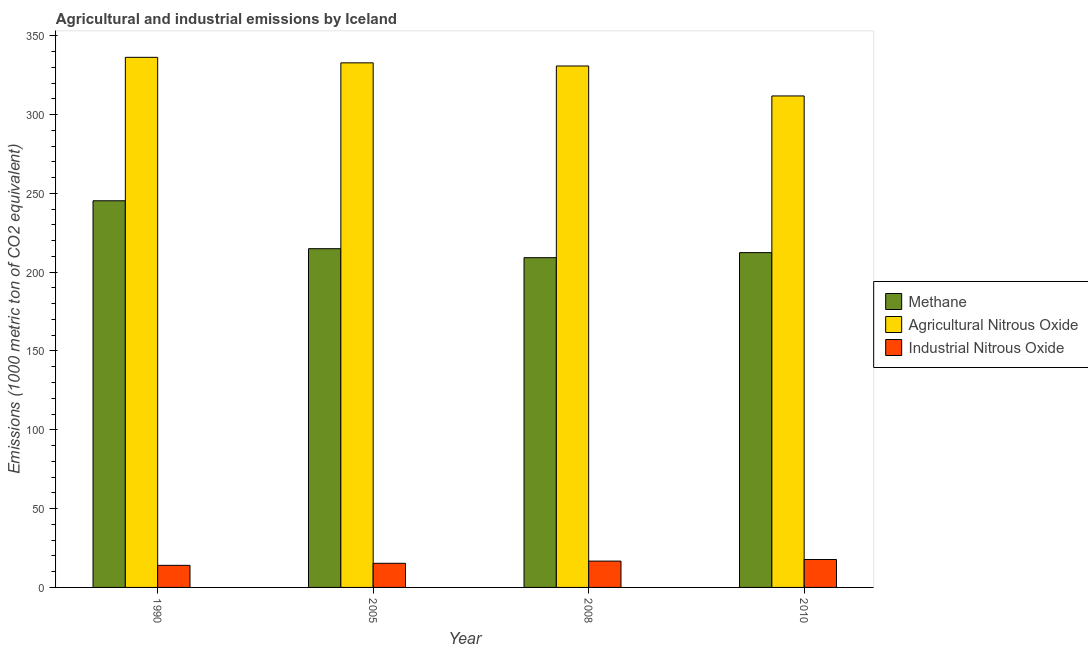Are the number of bars per tick equal to the number of legend labels?
Your response must be concise. Yes. Are the number of bars on each tick of the X-axis equal?
Make the answer very short. Yes. In how many cases, is the number of bars for a given year not equal to the number of legend labels?
Provide a short and direct response. 0. What is the amount of industrial nitrous oxide emissions in 2010?
Your response must be concise. 17.7. Across all years, what is the maximum amount of methane emissions?
Make the answer very short. 245.3. Across all years, what is the minimum amount of methane emissions?
Ensure brevity in your answer.  209.2. What is the total amount of agricultural nitrous oxide emissions in the graph?
Make the answer very short. 1311.7. What is the difference between the amount of industrial nitrous oxide emissions in 2005 and that in 2008?
Make the answer very short. -1.4. What is the difference between the amount of methane emissions in 2010 and the amount of industrial nitrous oxide emissions in 1990?
Keep it short and to the point. -32.9. What is the average amount of industrial nitrous oxide emissions per year?
Make the answer very short. 15.93. What is the ratio of the amount of industrial nitrous oxide emissions in 1990 to that in 2005?
Your answer should be compact. 0.92. Is the amount of methane emissions in 2005 less than that in 2010?
Give a very brief answer. No. What is the difference between the highest and the second highest amount of methane emissions?
Ensure brevity in your answer.  30.4. What is the difference between the highest and the lowest amount of methane emissions?
Give a very brief answer. 36.1. What does the 2nd bar from the left in 2005 represents?
Your response must be concise. Agricultural Nitrous Oxide. What does the 2nd bar from the right in 2005 represents?
Give a very brief answer. Agricultural Nitrous Oxide. Is it the case that in every year, the sum of the amount of methane emissions and amount of agricultural nitrous oxide emissions is greater than the amount of industrial nitrous oxide emissions?
Your response must be concise. Yes. Are all the bars in the graph horizontal?
Provide a succinct answer. No. How many years are there in the graph?
Provide a succinct answer. 4. What is the difference between two consecutive major ticks on the Y-axis?
Your response must be concise. 50. Are the values on the major ticks of Y-axis written in scientific E-notation?
Provide a short and direct response. No. Does the graph contain any zero values?
Make the answer very short. No. How many legend labels are there?
Keep it short and to the point. 3. What is the title of the graph?
Offer a terse response. Agricultural and industrial emissions by Iceland. What is the label or title of the Y-axis?
Provide a succinct answer. Emissions (1000 metric ton of CO2 equivalent). What is the Emissions (1000 metric ton of CO2 equivalent) in Methane in 1990?
Offer a terse response. 245.3. What is the Emissions (1000 metric ton of CO2 equivalent) of Agricultural Nitrous Oxide in 1990?
Provide a succinct answer. 336.3. What is the Emissions (1000 metric ton of CO2 equivalent) in Industrial Nitrous Oxide in 1990?
Provide a succinct answer. 14. What is the Emissions (1000 metric ton of CO2 equivalent) of Methane in 2005?
Provide a succinct answer. 214.9. What is the Emissions (1000 metric ton of CO2 equivalent) of Agricultural Nitrous Oxide in 2005?
Your answer should be very brief. 332.8. What is the Emissions (1000 metric ton of CO2 equivalent) in Industrial Nitrous Oxide in 2005?
Keep it short and to the point. 15.3. What is the Emissions (1000 metric ton of CO2 equivalent) in Methane in 2008?
Offer a very short reply. 209.2. What is the Emissions (1000 metric ton of CO2 equivalent) of Agricultural Nitrous Oxide in 2008?
Make the answer very short. 330.8. What is the Emissions (1000 metric ton of CO2 equivalent) of Industrial Nitrous Oxide in 2008?
Offer a very short reply. 16.7. What is the Emissions (1000 metric ton of CO2 equivalent) of Methane in 2010?
Ensure brevity in your answer.  212.4. What is the Emissions (1000 metric ton of CO2 equivalent) of Agricultural Nitrous Oxide in 2010?
Provide a succinct answer. 311.8. What is the Emissions (1000 metric ton of CO2 equivalent) in Industrial Nitrous Oxide in 2010?
Ensure brevity in your answer.  17.7. Across all years, what is the maximum Emissions (1000 metric ton of CO2 equivalent) of Methane?
Your response must be concise. 245.3. Across all years, what is the maximum Emissions (1000 metric ton of CO2 equivalent) in Agricultural Nitrous Oxide?
Make the answer very short. 336.3. Across all years, what is the minimum Emissions (1000 metric ton of CO2 equivalent) of Methane?
Offer a terse response. 209.2. Across all years, what is the minimum Emissions (1000 metric ton of CO2 equivalent) in Agricultural Nitrous Oxide?
Ensure brevity in your answer.  311.8. Across all years, what is the minimum Emissions (1000 metric ton of CO2 equivalent) of Industrial Nitrous Oxide?
Provide a short and direct response. 14. What is the total Emissions (1000 metric ton of CO2 equivalent) of Methane in the graph?
Provide a succinct answer. 881.8. What is the total Emissions (1000 metric ton of CO2 equivalent) in Agricultural Nitrous Oxide in the graph?
Your response must be concise. 1311.7. What is the total Emissions (1000 metric ton of CO2 equivalent) in Industrial Nitrous Oxide in the graph?
Your answer should be compact. 63.7. What is the difference between the Emissions (1000 metric ton of CO2 equivalent) of Methane in 1990 and that in 2005?
Your response must be concise. 30.4. What is the difference between the Emissions (1000 metric ton of CO2 equivalent) of Industrial Nitrous Oxide in 1990 and that in 2005?
Give a very brief answer. -1.3. What is the difference between the Emissions (1000 metric ton of CO2 equivalent) in Methane in 1990 and that in 2008?
Offer a very short reply. 36.1. What is the difference between the Emissions (1000 metric ton of CO2 equivalent) of Agricultural Nitrous Oxide in 1990 and that in 2008?
Offer a terse response. 5.5. What is the difference between the Emissions (1000 metric ton of CO2 equivalent) in Industrial Nitrous Oxide in 1990 and that in 2008?
Keep it short and to the point. -2.7. What is the difference between the Emissions (1000 metric ton of CO2 equivalent) in Methane in 1990 and that in 2010?
Ensure brevity in your answer.  32.9. What is the difference between the Emissions (1000 metric ton of CO2 equivalent) of Industrial Nitrous Oxide in 1990 and that in 2010?
Give a very brief answer. -3.7. What is the difference between the Emissions (1000 metric ton of CO2 equivalent) of Methane in 2005 and that in 2008?
Your response must be concise. 5.7. What is the difference between the Emissions (1000 metric ton of CO2 equivalent) in Methane in 2005 and that in 2010?
Provide a short and direct response. 2.5. What is the difference between the Emissions (1000 metric ton of CO2 equivalent) of Methane in 2008 and that in 2010?
Your response must be concise. -3.2. What is the difference between the Emissions (1000 metric ton of CO2 equivalent) of Agricultural Nitrous Oxide in 2008 and that in 2010?
Offer a very short reply. 19. What is the difference between the Emissions (1000 metric ton of CO2 equivalent) in Industrial Nitrous Oxide in 2008 and that in 2010?
Offer a very short reply. -1. What is the difference between the Emissions (1000 metric ton of CO2 equivalent) in Methane in 1990 and the Emissions (1000 metric ton of CO2 equivalent) in Agricultural Nitrous Oxide in 2005?
Make the answer very short. -87.5. What is the difference between the Emissions (1000 metric ton of CO2 equivalent) in Methane in 1990 and the Emissions (1000 metric ton of CO2 equivalent) in Industrial Nitrous Oxide in 2005?
Provide a short and direct response. 230. What is the difference between the Emissions (1000 metric ton of CO2 equivalent) in Agricultural Nitrous Oxide in 1990 and the Emissions (1000 metric ton of CO2 equivalent) in Industrial Nitrous Oxide in 2005?
Your answer should be very brief. 321. What is the difference between the Emissions (1000 metric ton of CO2 equivalent) of Methane in 1990 and the Emissions (1000 metric ton of CO2 equivalent) of Agricultural Nitrous Oxide in 2008?
Ensure brevity in your answer.  -85.5. What is the difference between the Emissions (1000 metric ton of CO2 equivalent) of Methane in 1990 and the Emissions (1000 metric ton of CO2 equivalent) of Industrial Nitrous Oxide in 2008?
Provide a succinct answer. 228.6. What is the difference between the Emissions (1000 metric ton of CO2 equivalent) in Agricultural Nitrous Oxide in 1990 and the Emissions (1000 metric ton of CO2 equivalent) in Industrial Nitrous Oxide in 2008?
Offer a terse response. 319.6. What is the difference between the Emissions (1000 metric ton of CO2 equivalent) of Methane in 1990 and the Emissions (1000 metric ton of CO2 equivalent) of Agricultural Nitrous Oxide in 2010?
Your answer should be compact. -66.5. What is the difference between the Emissions (1000 metric ton of CO2 equivalent) in Methane in 1990 and the Emissions (1000 metric ton of CO2 equivalent) in Industrial Nitrous Oxide in 2010?
Ensure brevity in your answer.  227.6. What is the difference between the Emissions (1000 metric ton of CO2 equivalent) in Agricultural Nitrous Oxide in 1990 and the Emissions (1000 metric ton of CO2 equivalent) in Industrial Nitrous Oxide in 2010?
Give a very brief answer. 318.6. What is the difference between the Emissions (1000 metric ton of CO2 equivalent) in Methane in 2005 and the Emissions (1000 metric ton of CO2 equivalent) in Agricultural Nitrous Oxide in 2008?
Make the answer very short. -115.9. What is the difference between the Emissions (1000 metric ton of CO2 equivalent) in Methane in 2005 and the Emissions (1000 metric ton of CO2 equivalent) in Industrial Nitrous Oxide in 2008?
Make the answer very short. 198.2. What is the difference between the Emissions (1000 metric ton of CO2 equivalent) in Agricultural Nitrous Oxide in 2005 and the Emissions (1000 metric ton of CO2 equivalent) in Industrial Nitrous Oxide in 2008?
Your answer should be compact. 316.1. What is the difference between the Emissions (1000 metric ton of CO2 equivalent) in Methane in 2005 and the Emissions (1000 metric ton of CO2 equivalent) in Agricultural Nitrous Oxide in 2010?
Give a very brief answer. -96.9. What is the difference between the Emissions (1000 metric ton of CO2 equivalent) of Methane in 2005 and the Emissions (1000 metric ton of CO2 equivalent) of Industrial Nitrous Oxide in 2010?
Ensure brevity in your answer.  197.2. What is the difference between the Emissions (1000 metric ton of CO2 equivalent) in Agricultural Nitrous Oxide in 2005 and the Emissions (1000 metric ton of CO2 equivalent) in Industrial Nitrous Oxide in 2010?
Your answer should be very brief. 315.1. What is the difference between the Emissions (1000 metric ton of CO2 equivalent) of Methane in 2008 and the Emissions (1000 metric ton of CO2 equivalent) of Agricultural Nitrous Oxide in 2010?
Keep it short and to the point. -102.6. What is the difference between the Emissions (1000 metric ton of CO2 equivalent) of Methane in 2008 and the Emissions (1000 metric ton of CO2 equivalent) of Industrial Nitrous Oxide in 2010?
Your answer should be very brief. 191.5. What is the difference between the Emissions (1000 metric ton of CO2 equivalent) in Agricultural Nitrous Oxide in 2008 and the Emissions (1000 metric ton of CO2 equivalent) in Industrial Nitrous Oxide in 2010?
Provide a short and direct response. 313.1. What is the average Emissions (1000 metric ton of CO2 equivalent) in Methane per year?
Your response must be concise. 220.45. What is the average Emissions (1000 metric ton of CO2 equivalent) of Agricultural Nitrous Oxide per year?
Ensure brevity in your answer.  327.93. What is the average Emissions (1000 metric ton of CO2 equivalent) of Industrial Nitrous Oxide per year?
Your answer should be compact. 15.93. In the year 1990, what is the difference between the Emissions (1000 metric ton of CO2 equivalent) in Methane and Emissions (1000 metric ton of CO2 equivalent) in Agricultural Nitrous Oxide?
Keep it short and to the point. -91. In the year 1990, what is the difference between the Emissions (1000 metric ton of CO2 equivalent) in Methane and Emissions (1000 metric ton of CO2 equivalent) in Industrial Nitrous Oxide?
Provide a succinct answer. 231.3. In the year 1990, what is the difference between the Emissions (1000 metric ton of CO2 equivalent) in Agricultural Nitrous Oxide and Emissions (1000 metric ton of CO2 equivalent) in Industrial Nitrous Oxide?
Offer a terse response. 322.3. In the year 2005, what is the difference between the Emissions (1000 metric ton of CO2 equivalent) of Methane and Emissions (1000 metric ton of CO2 equivalent) of Agricultural Nitrous Oxide?
Make the answer very short. -117.9. In the year 2005, what is the difference between the Emissions (1000 metric ton of CO2 equivalent) in Methane and Emissions (1000 metric ton of CO2 equivalent) in Industrial Nitrous Oxide?
Give a very brief answer. 199.6. In the year 2005, what is the difference between the Emissions (1000 metric ton of CO2 equivalent) in Agricultural Nitrous Oxide and Emissions (1000 metric ton of CO2 equivalent) in Industrial Nitrous Oxide?
Keep it short and to the point. 317.5. In the year 2008, what is the difference between the Emissions (1000 metric ton of CO2 equivalent) in Methane and Emissions (1000 metric ton of CO2 equivalent) in Agricultural Nitrous Oxide?
Your answer should be very brief. -121.6. In the year 2008, what is the difference between the Emissions (1000 metric ton of CO2 equivalent) in Methane and Emissions (1000 metric ton of CO2 equivalent) in Industrial Nitrous Oxide?
Ensure brevity in your answer.  192.5. In the year 2008, what is the difference between the Emissions (1000 metric ton of CO2 equivalent) in Agricultural Nitrous Oxide and Emissions (1000 metric ton of CO2 equivalent) in Industrial Nitrous Oxide?
Your answer should be very brief. 314.1. In the year 2010, what is the difference between the Emissions (1000 metric ton of CO2 equivalent) of Methane and Emissions (1000 metric ton of CO2 equivalent) of Agricultural Nitrous Oxide?
Provide a succinct answer. -99.4. In the year 2010, what is the difference between the Emissions (1000 metric ton of CO2 equivalent) in Methane and Emissions (1000 metric ton of CO2 equivalent) in Industrial Nitrous Oxide?
Give a very brief answer. 194.7. In the year 2010, what is the difference between the Emissions (1000 metric ton of CO2 equivalent) in Agricultural Nitrous Oxide and Emissions (1000 metric ton of CO2 equivalent) in Industrial Nitrous Oxide?
Provide a succinct answer. 294.1. What is the ratio of the Emissions (1000 metric ton of CO2 equivalent) in Methane in 1990 to that in 2005?
Your answer should be compact. 1.14. What is the ratio of the Emissions (1000 metric ton of CO2 equivalent) of Agricultural Nitrous Oxide in 1990 to that in 2005?
Your answer should be very brief. 1.01. What is the ratio of the Emissions (1000 metric ton of CO2 equivalent) of Industrial Nitrous Oxide in 1990 to that in 2005?
Provide a succinct answer. 0.92. What is the ratio of the Emissions (1000 metric ton of CO2 equivalent) in Methane in 1990 to that in 2008?
Offer a terse response. 1.17. What is the ratio of the Emissions (1000 metric ton of CO2 equivalent) of Agricultural Nitrous Oxide in 1990 to that in 2008?
Provide a short and direct response. 1.02. What is the ratio of the Emissions (1000 metric ton of CO2 equivalent) of Industrial Nitrous Oxide in 1990 to that in 2008?
Ensure brevity in your answer.  0.84. What is the ratio of the Emissions (1000 metric ton of CO2 equivalent) of Methane in 1990 to that in 2010?
Your answer should be compact. 1.15. What is the ratio of the Emissions (1000 metric ton of CO2 equivalent) of Agricultural Nitrous Oxide in 1990 to that in 2010?
Keep it short and to the point. 1.08. What is the ratio of the Emissions (1000 metric ton of CO2 equivalent) in Industrial Nitrous Oxide in 1990 to that in 2010?
Your response must be concise. 0.79. What is the ratio of the Emissions (1000 metric ton of CO2 equivalent) of Methane in 2005 to that in 2008?
Make the answer very short. 1.03. What is the ratio of the Emissions (1000 metric ton of CO2 equivalent) of Agricultural Nitrous Oxide in 2005 to that in 2008?
Your answer should be very brief. 1.01. What is the ratio of the Emissions (1000 metric ton of CO2 equivalent) of Industrial Nitrous Oxide in 2005 to that in 2008?
Give a very brief answer. 0.92. What is the ratio of the Emissions (1000 metric ton of CO2 equivalent) of Methane in 2005 to that in 2010?
Give a very brief answer. 1.01. What is the ratio of the Emissions (1000 metric ton of CO2 equivalent) of Agricultural Nitrous Oxide in 2005 to that in 2010?
Keep it short and to the point. 1.07. What is the ratio of the Emissions (1000 metric ton of CO2 equivalent) of Industrial Nitrous Oxide in 2005 to that in 2010?
Provide a succinct answer. 0.86. What is the ratio of the Emissions (1000 metric ton of CO2 equivalent) of Methane in 2008 to that in 2010?
Keep it short and to the point. 0.98. What is the ratio of the Emissions (1000 metric ton of CO2 equivalent) in Agricultural Nitrous Oxide in 2008 to that in 2010?
Your answer should be compact. 1.06. What is the ratio of the Emissions (1000 metric ton of CO2 equivalent) of Industrial Nitrous Oxide in 2008 to that in 2010?
Keep it short and to the point. 0.94. What is the difference between the highest and the second highest Emissions (1000 metric ton of CO2 equivalent) in Methane?
Offer a very short reply. 30.4. What is the difference between the highest and the second highest Emissions (1000 metric ton of CO2 equivalent) of Agricultural Nitrous Oxide?
Provide a succinct answer. 3.5. What is the difference between the highest and the lowest Emissions (1000 metric ton of CO2 equivalent) of Methane?
Give a very brief answer. 36.1. What is the difference between the highest and the lowest Emissions (1000 metric ton of CO2 equivalent) in Industrial Nitrous Oxide?
Keep it short and to the point. 3.7. 